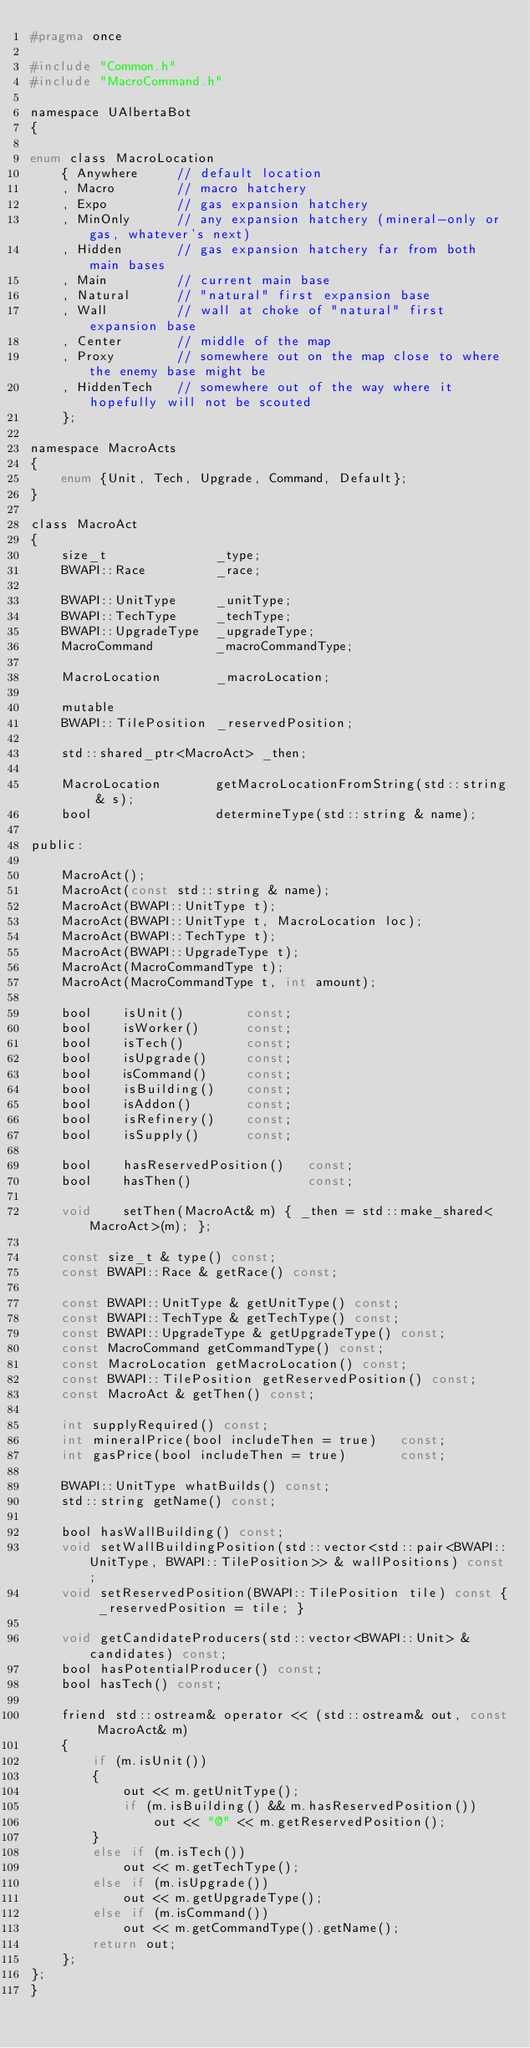Convert code to text. <code><loc_0><loc_0><loc_500><loc_500><_C_>#pragma once

#include "Common.h"
#include "MacroCommand.h"

namespace UAlbertaBot
{

enum class MacroLocation
	{ Anywhere     // default location
	, Macro        // macro hatchery
	, Expo         // gas expansion hatchery
	, MinOnly      // any expansion hatchery (mineral-only or gas, whatever's next)
	, Hidden       // gas expansion hatchery far from both main bases
	, Main         // current main base
	, Natural      // "natural" first expansion base
	, Wall         // wall at choke of "natural" first expansion base
	, Center       // middle of the map
	, Proxy        // somewhere out on the map close to where the enemy base might be
	, HiddenTech   // somewhere out of the way where it hopefully will not be scouted
	};

namespace MacroActs
{
    enum {Unit, Tech, Upgrade, Command, Default};
}

class MacroAct 
{
	size_t				_type;
    BWAPI::Race			_race;

	BWAPI::UnitType		_unitType;
	BWAPI::TechType		_techType;
	BWAPI::UpgradeType	_upgradeType;
	MacroCommand		_macroCommandType;

	MacroLocation		_macroLocation;

	mutable
	BWAPI::TilePosition _reservedPosition;

    std::shared_ptr<MacroAct> _then;

	MacroLocation		getMacroLocationFromString(std::string & s);
	bool				determineType(std::string & name);

public:

	MacroAct();
    MacroAct(const std::string & name);
	MacroAct(BWAPI::UnitType t);
	MacroAct(BWAPI::UnitType t, MacroLocation loc);
	MacroAct(BWAPI::TechType t);
	MacroAct(BWAPI::UpgradeType t);
	MacroAct(MacroCommandType t);
	MacroAct(MacroCommandType t, int amount);

	bool    isUnit()		const;
	bool	isWorker()		const;
	bool    isTech()		const;
	bool    isUpgrade()	    const;
	bool    isCommand()	    const;
	bool    isBuilding()	const;
	bool	isAddon()		const;
	bool    isRefinery()	const;
	bool	isSupply()		const;
    
	bool    hasReservedPosition()	const;
	bool	hasThen()				const;

    void    setThen(MacroAct& m) { _then = std::make_shared<MacroAct>(m); };

    const size_t & type() const;
    const BWAPI::Race & getRace() const;

    const BWAPI::UnitType & getUnitType() const;
    const BWAPI::TechType & getTechType() const;
    const BWAPI::UpgradeType & getUpgradeType() const;
	const MacroCommand getCommandType() const;
	const MacroLocation getMacroLocation() const;
	const BWAPI::TilePosition getReservedPosition() const;
	const MacroAct & getThen() const;

	int supplyRequired() const;
	int mineralPrice(bool includeThen = true)   const;
	int gasPrice(bool includeThen = true)       const;

	BWAPI::UnitType whatBuilds() const;
	std::string getName() const;

	bool hasWallBuilding() const;
	void setWallBuildingPosition(std::vector<std::pair<BWAPI::UnitType, BWAPI::TilePosition>> & wallPositions) const;
	void setReservedPosition(BWAPI::TilePosition tile) const { _reservedPosition = tile; }

	void getCandidateProducers(std::vector<BWAPI::Unit> & candidates) const;
	bool hasPotentialProducer() const;
	bool hasTech() const;

	friend std::ostream& operator << (std::ostream& out, const MacroAct& m)
	{
		if (m.isUnit())
		{
			out << m.getUnitType();
			if (m.isBuilding() && m.hasReservedPosition())
				out << "@" << m.getReservedPosition();
		}
		else if (m.isTech())
			out << m.getTechType();
		else if (m.isUpgrade())
			out << m.getUpgradeType();
		else if (m.isCommand())
			out << m.getCommandType().getName();
		return out;
	};
};
}</code> 